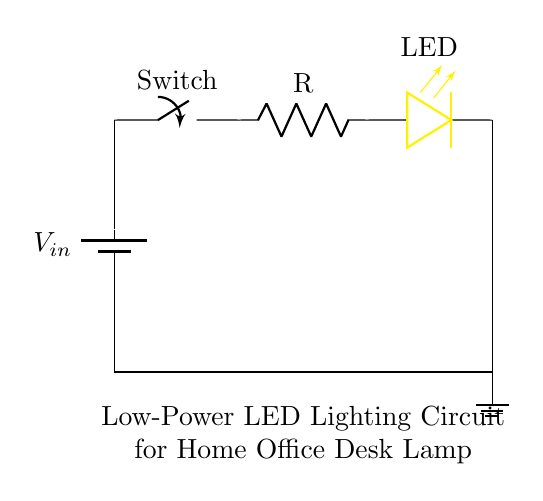What is the primary function of the switch in this circuit? The switch in this circuit controls the flow of electricity; it can either allow current to pass through when closed or stop it when open.
Answer: Controls electricity What component limits the current in the circuit? The resistor is responsible for limiting the current passing through the LED, preventing it from drawing excessive current and potentially being damaged.
Answer: Resistor What color is the LED used in this circuit? The LED in this circuit is colored yellow, which is indicated by the description provided in the diagram.
Answer: Yellow What is the total voltage supplied by the battery? The circuit diagram does not provide an explicit voltage value for the battery, but it is labeled as Vin, indicating it could be any appropriate low voltage for LEDs.
Answer: Vin How is the LED connected in the circuit? The LED is connected in series after the current-limiting resistor, meaning current flows from the battery, through the switch, the resistor, and then the LED before returning to ground.
Answer: In series What is the purpose of including a ground in the circuit? The ground provides a common reference point for the voltage levels in the circuit, completing the circuit path, and ensuring safe operation by providing a return path for current.
Answer: Common reference What feature makes this a low-power circuit? The combination of a resistor with a low-voltage LED ensures that the total power consumption remains low, suitable for applications where minimal energy is desired.
Answer: Low voltage and resistor 